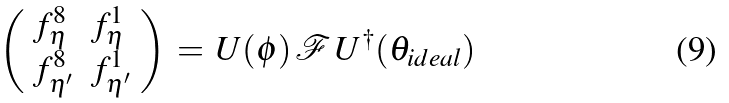Convert formula to latex. <formula><loc_0><loc_0><loc_500><loc_500>\left ( \begin{array} { l l } { { f _ { \eta } ^ { 8 } } } & { { f _ { \eta } ^ { 1 } } } \\ { { f _ { \eta ^ { \prime } } ^ { 8 } } } & { { f _ { \eta ^ { \prime } } ^ { 1 } } } \end{array} \right ) \, = \, U ( \phi ) \, { \mathcal { F } } \, U ^ { \dagger } ( \theta _ { i d e a l } )</formula> 